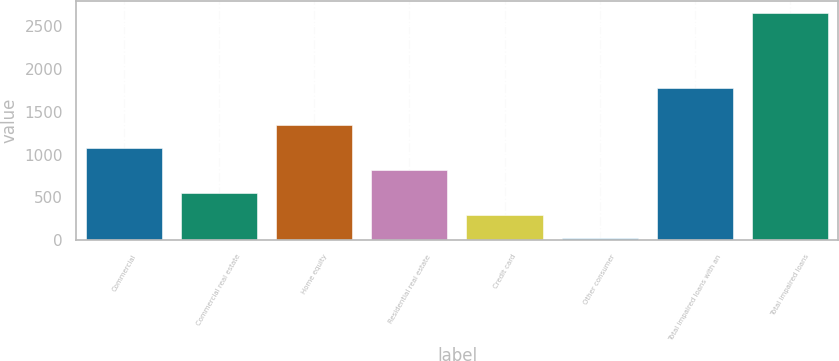<chart> <loc_0><loc_0><loc_500><loc_500><bar_chart><fcel>Commercial<fcel>Commercial real estate<fcel>Home equity<fcel>Residential real estate<fcel>Credit card<fcel>Other consumer<fcel>Total impaired loans with an<fcel>Total impaired loans<nl><fcel>1079.6<fcel>552.8<fcel>1343<fcel>816.2<fcel>289.4<fcel>26<fcel>1774<fcel>2660<nl></chart> 